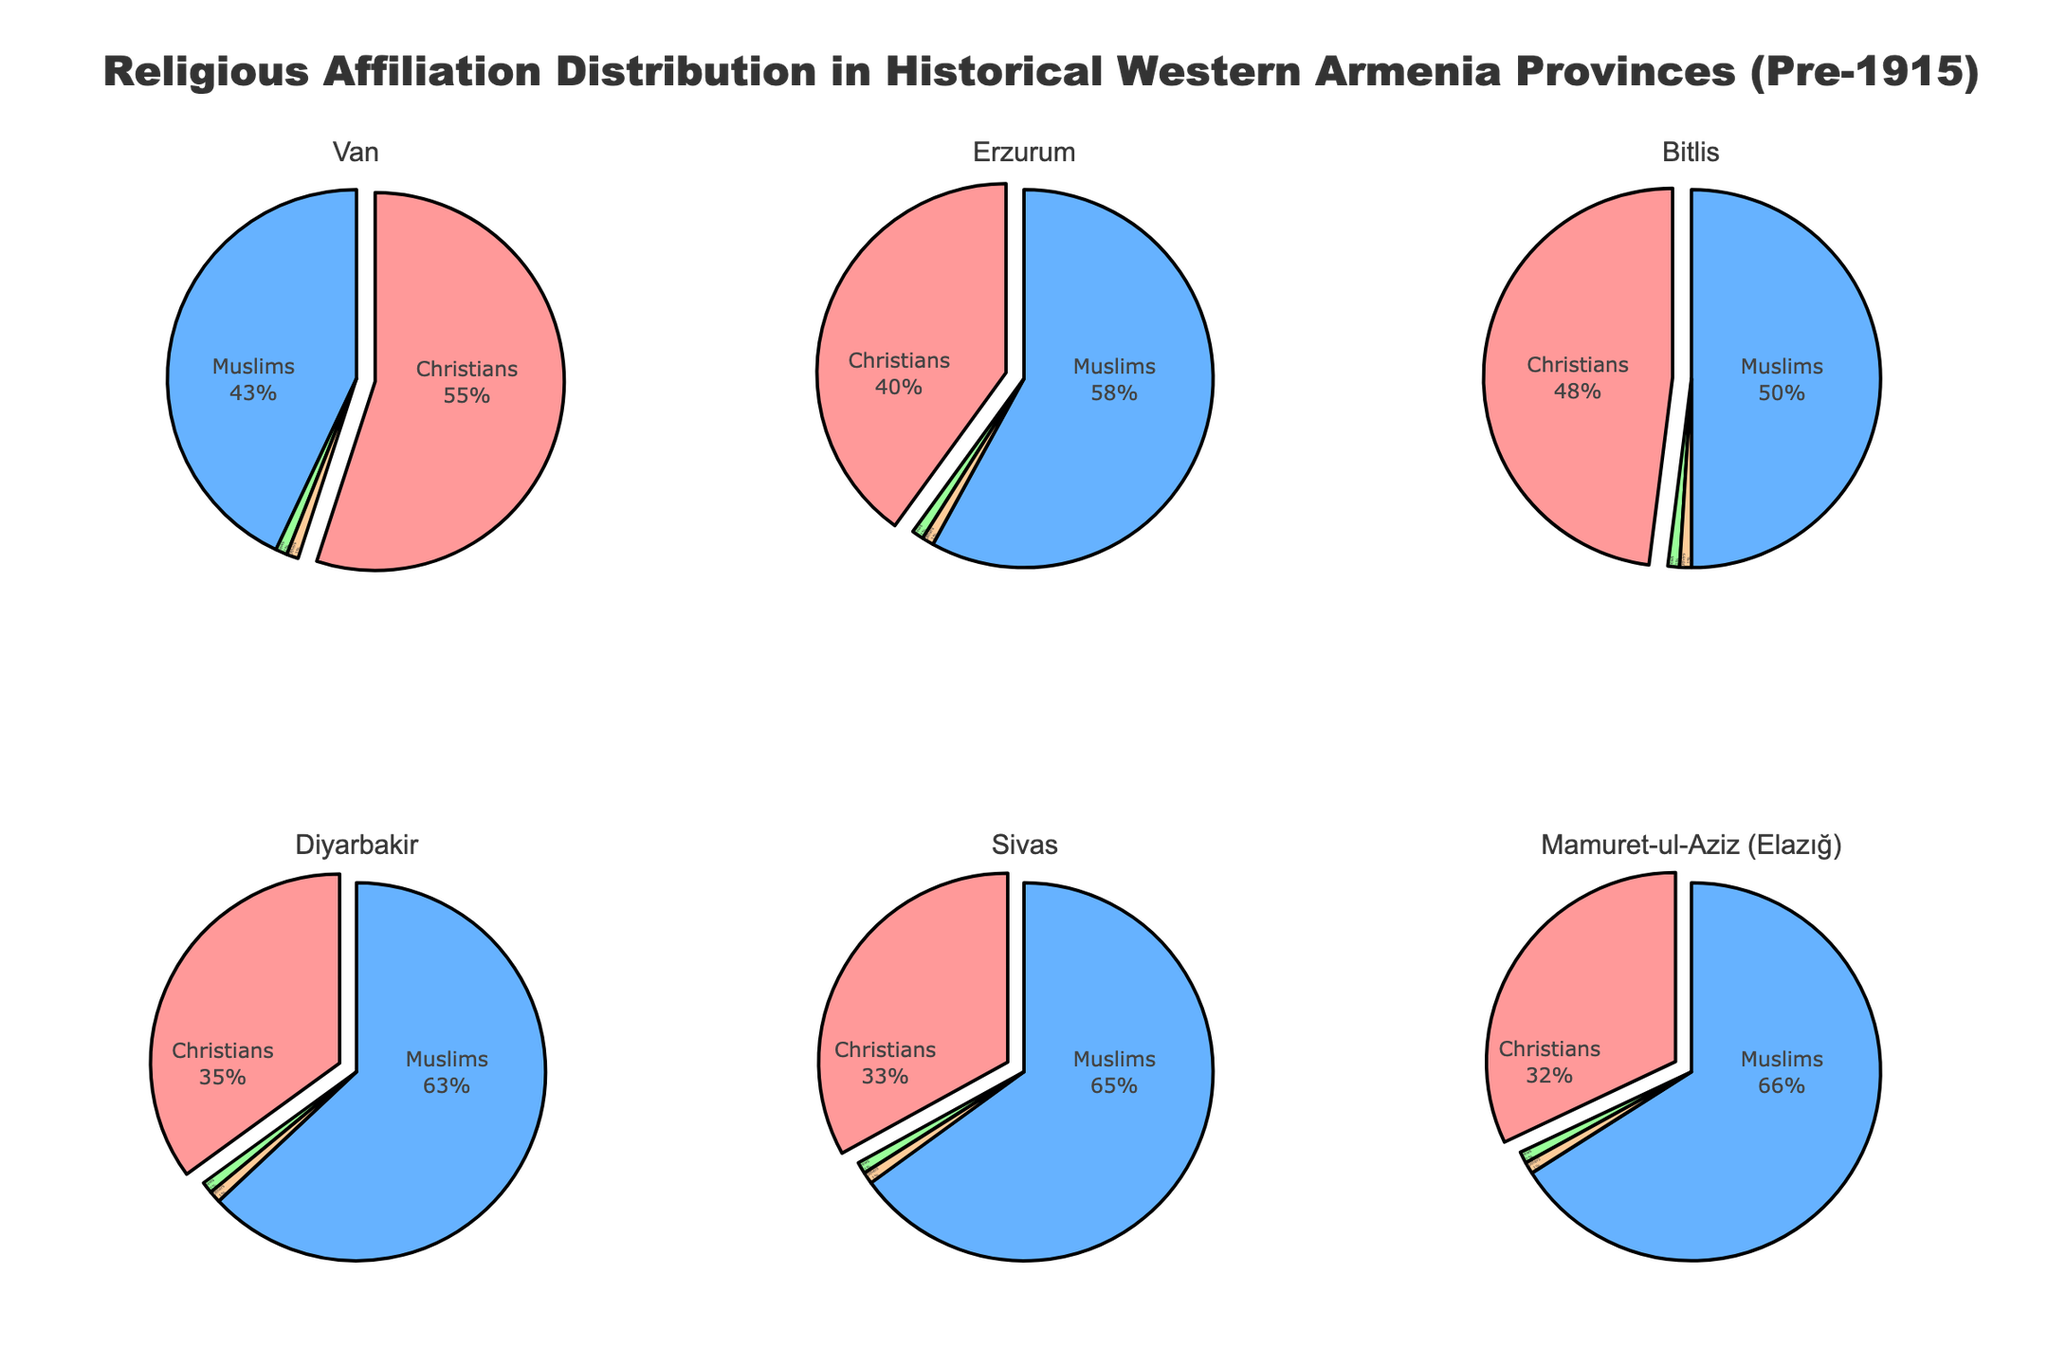What is the title of the figure? The title of the figure is located at the top and is usually larger and bolder than other text. It provides an overview of what the figure represents.
Answer: Religious Affiliation Distribution in Historical Western Armenia Provinces (Pre-1915) Which province has the highest percentage of Christians? To determine this, look at each pie chart and compare the percentage slices that represent Christians. The province with the largest slice will be the answer.
Answer: Van What is the sum of Christians and Muslims in the Diyarbakir province? First, identify the percentages for Christians and Muslims in the Diyarbakir pie chart. Then add these two percentages together. Christians (35%) + Muslims (63%) = 98%
Answer: 98% In which provinces do Muslims comprise more than 60% of the population? Examine the pie charts and identify the provinces where the Muslim portion of the pie chart exceeds 60%.
Answer: Diyarbakir, Sivas, Mamuret-ul-Aziz (Elazığ) Compare the percentage of Jews across the provinces. Is the percentage the same in all provinces? Look at the pie charts and compare the Jewish percentage slices across all the provinces to see if they are equal.
Answer: Yes Which province has the smallest percentage of Christians? Compare the Christian slices across all provinces to find the smallest one.
Answer: Mamuret-ul-Aziz (Elazığ) What is the average percentage of Christians across all the provinces? Add the Christian percentages from all six provinces and divide by the number of provinces: (55 + 40 + 48 + 35 + 33 + 32) / 6. Detailed calculation: 243 / 6 = 40.5
Answer: 40.5% Is there any province where 'Others' make up a significant portion of the population? Check each pie chart's 'Others' slice to see if it is significantly larger than 1%.
Answer: No How does the religious distribution in Van compare to Bitlis in terms of Christians and Muslims? Compare the percentages of Christians and Muslims in the Van pie chart with those in the Bitlis pie chart. Van: Christians 55%, Muslims 43%. Bitlis: Christians 48%, Muslims 50%. Detailed explanation: In Van, Christians are the majority, whereas in Bitlis, Muslims are slightly more than Christians.
Answer: Van has more Christians than Bitlis, Bitlis has more Muslims than Van Which provinces have a more balanced distribution of Christians and Muslims? Look at the pie charts and identify provinces where the Christian and Muslim percentages are nearly equal.
Answer: Bitlis 